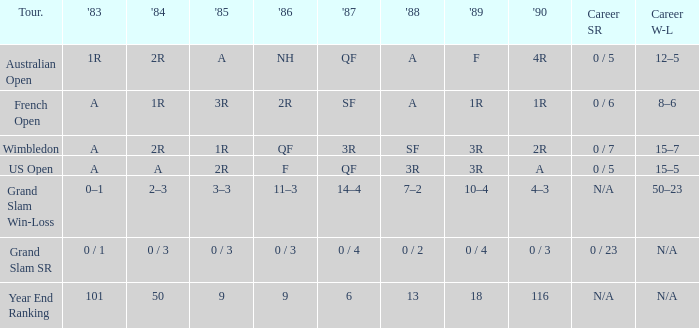Would you mind parsing the complete table? {'header': ['Tour.', "'83", "'84", "'85", "'86", "'87", "'88", "'89", "'90", 'Career SR', 'Career W-L'], 'rows': [['Australian Open', '1R', '2R', 'A', 'NH', 'QF', 'A', 'F', '4R', '0 / 5', '12–5'], ['French Open', 'A', '1R', '3R', '2R', 'SF', 'A', '1R', '1R', '0 / 6', '8–6'], ['Wimbledon', 'A', '2R', '1R', 'QF', '3R', 'SF', '3R', '2R', '0 / 7', '15–7'], ['US Open', 'A', 'A', '2R', 'F', 'QF', '3R', '3R', 'A', '0 / 5', '15–5'], ['Grand Slam Win-Loss', '0–1', '2–3', '3–3', '11–3', '14–4', '7–2', '10–4', '4–3', 'N/A', '50–23'], ['Grand Slam SR', '0 / 1', '0 / 3', '0 / 3', '0 / 3', '0 / 4', '0 / 2', '0 / 4', '0 / 3', '0 / 23', 'N/A'], ['Year End Ranking', '101', '50', '9', '9', '6', '13', '18', '116', 'N/A', 'N/A']]} What tournament has 0 / 5 as career SR and A as 1983? US Open. 